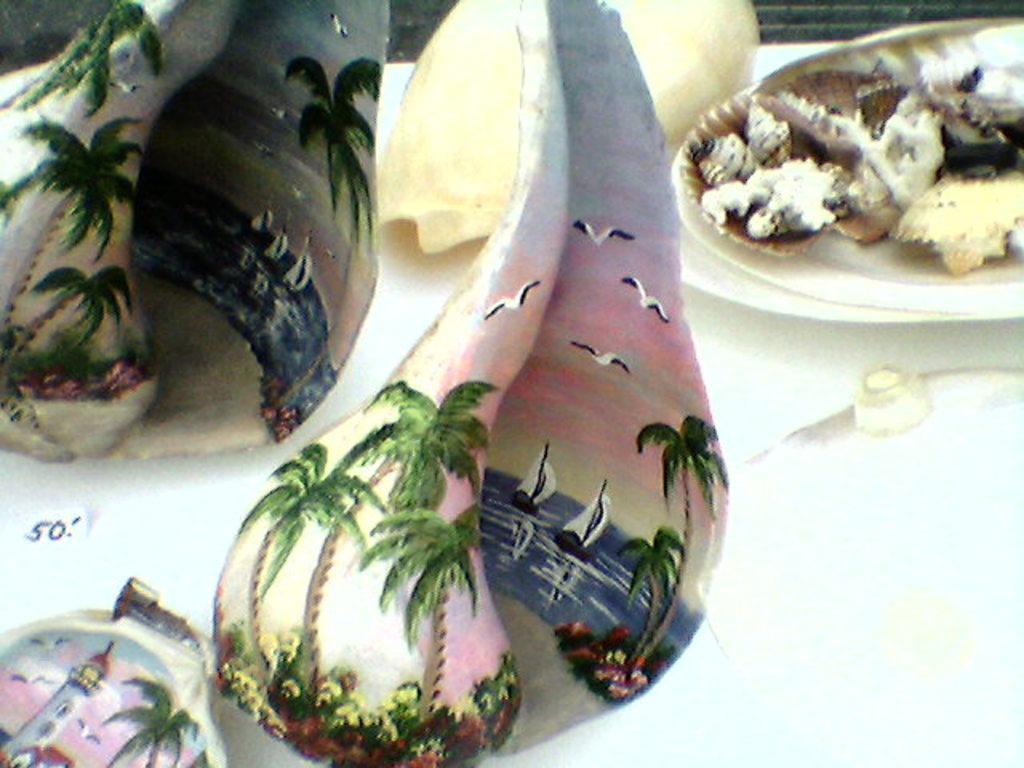Please provide a concise description of this image. In this image we can see paintings on the shells on the white color surface. 